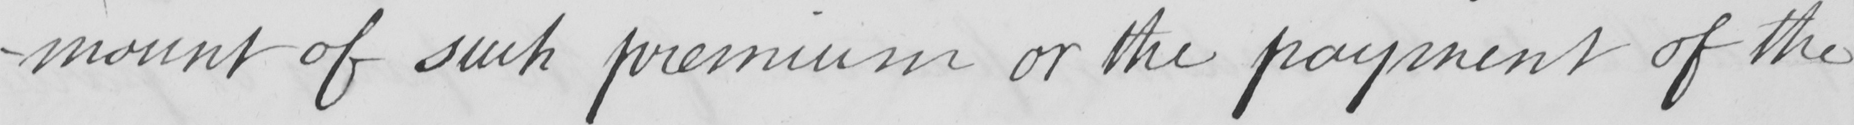Can you read and transcribe this handwriting? -mount of such premium or the payment of the 